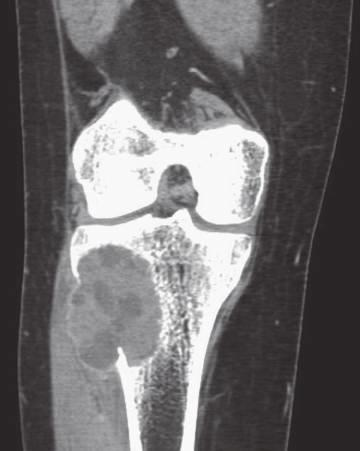does the coronal compute axial tomography scan show eccentric aneurysmal bone cyst of tibia?
Answer the question using a single word or phrase. Yes 